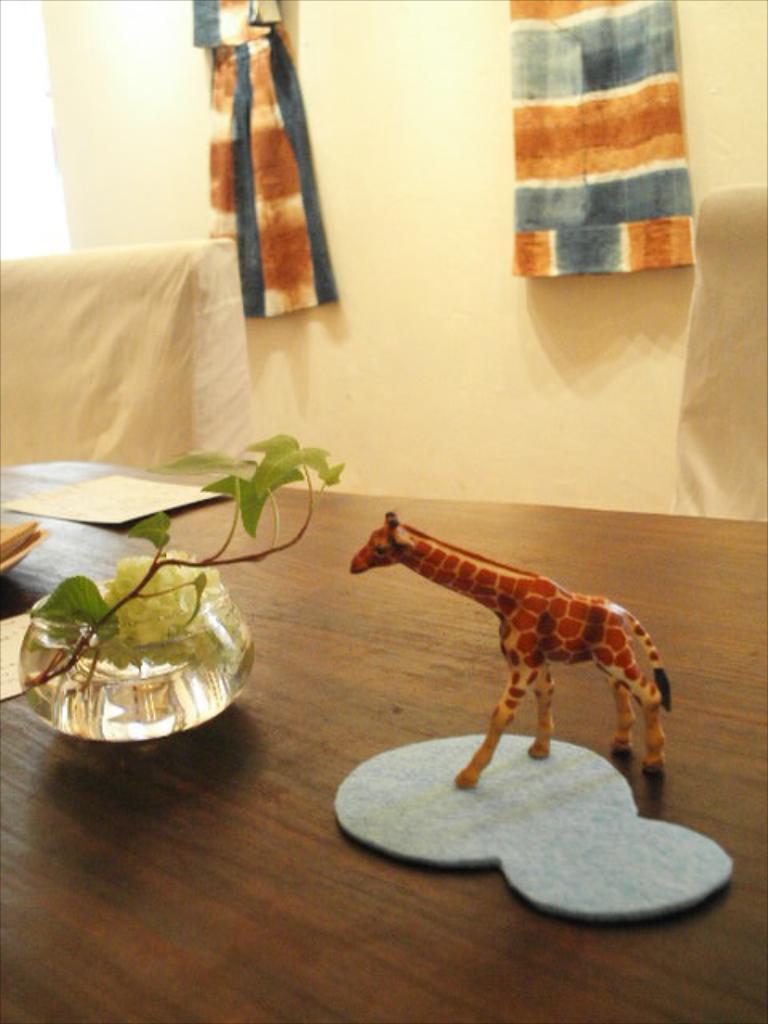What piece of furniture is present in the image? There is a table in the image. What objects are on the table? There is a toy, a house plant, and a paper on the table. What type of seating is visible in the image? There is a chair in the image. What can be seen in the background of the image? There is a wall in the background of the image. What other item is present in the image? There is a cloth in the image. What type of stamp can be seen on the toy in the image? There is no stamp visible on the toy in the image. How many stars are present on the wall in the image? There is no mention of stars on the wall in the image. 